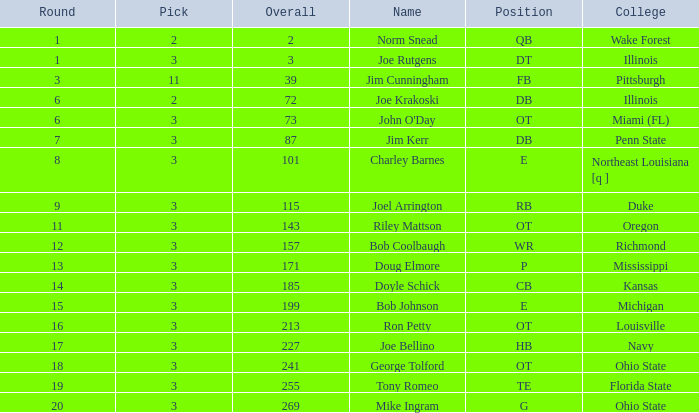Write the full table. {'header': ['Round', 'Pick', 'Overall', 'Name', 'Position', 'College'], 'rows': [['1', '2', '2', 'Norm Snead', 'QB', 'Wake Forest'], ['1', '3', '3', 'Joe Rutgens', 'DT', 'Illinois'], ['3', '11', '39', 'Jim Cunningham', 'FB', 'Pittsburgh'], ['6', '2', '72', 'Joe Krakoski', 'DB', 'Illinois'], ['6', '3', '73', "John O'Day", 'OT', 'Miami (FL)'], ['7', '3', '87', 'Jim Kerr', 'DB', 'Penn State'], ['8', '3', '101', 'Charley Barnes', 'E', 'Northeast Louisiana [q ]'], ['9', '3', '115', 'Joel Arrington', 'RB', 'Duke'], ['11', '3', '143', 'Riley Mattson', 'OT', 'Oregon'], ['12', '3', '157', 'Bob Coolbaugh', 'WR', 'Richmond'], ['13', '3', '171', 'Doug Elmore', 'P', 'Mississippi'], ['14', '3', '185', 'Doyle Schick', 'CB', 'Kansas'], ['15', '3', '199', 'Bob Johnson', 'E', 'Michigan'], ['16', '3', '213', 'Ron Petty', 'OT', 'Louisville'], ['17', '3', '227', 'Joe Bellino', 'HB', 'Navy'], ['18', '3', '241', 'George Tolford', 'OT', 'Ohio State'], ['19', '3', '255', 'Tony Romeo', 'TE', 'Florida State'], ['20', '3', '269', 'Mike Ingram', 'G', 'Ohio State']]} What is the quantity of overalls named charley barnes with a pick less than 3? None. 